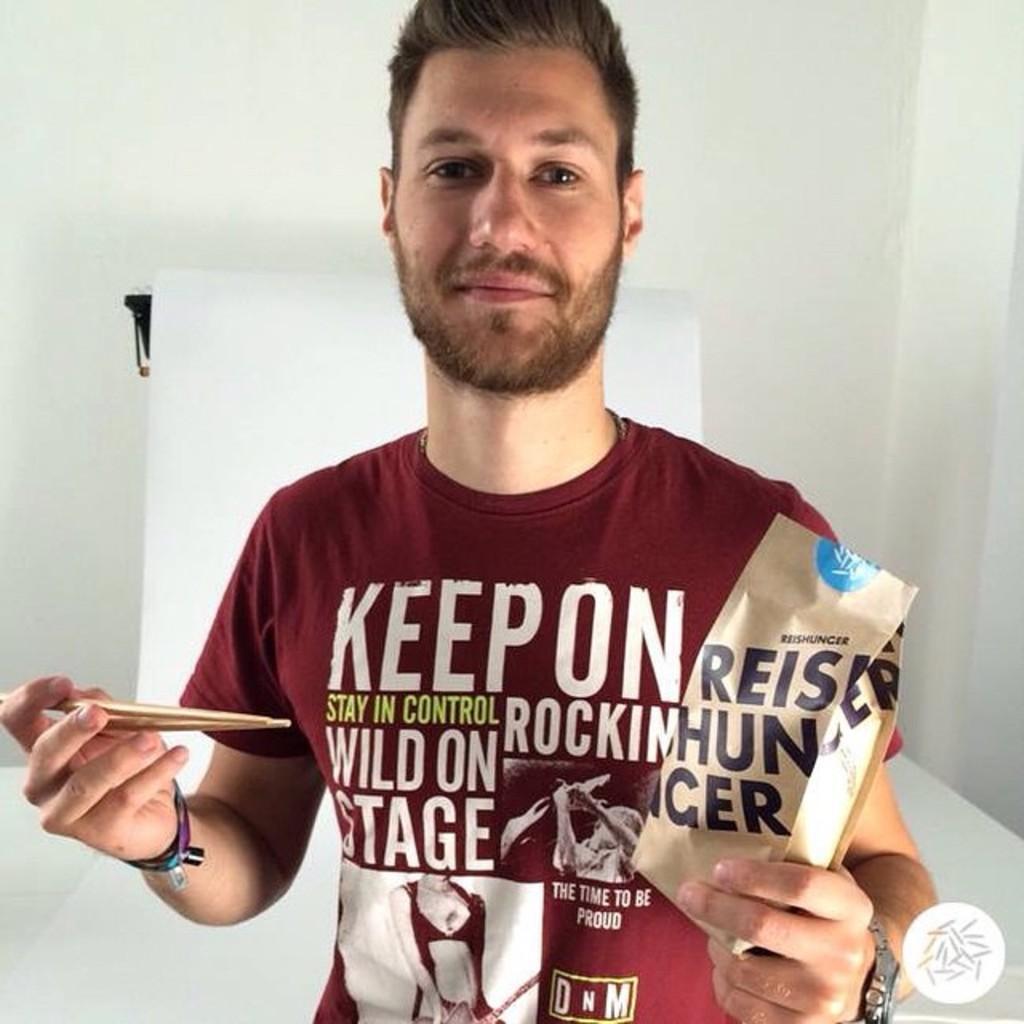Can you describe this image briefly? In this picture we can see a man is holding a paper bag and chopsticks, he wore a t-shirt and a watch, in the background there is a wall, we can see some text on this t-shirt, at the right bottom it looks like a logo. 